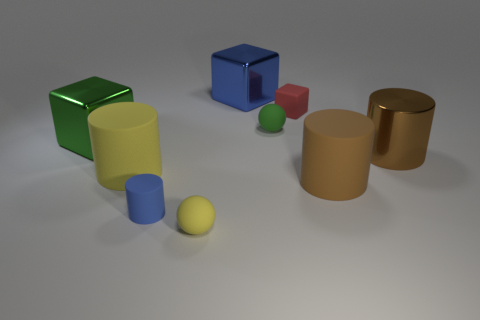Are the blue object in front of the green metal thing and the tiny green sphere made of the same material?
Your answer should be very brief. Yes. Are there the same number of small green spheres that are on the right side of the green matte object and brown things that are right of the big brown rubber cylinder?
Make the answer very short. No. What material is the other cylinder that is the same color as the shiny cylinder?
Keep it short and to the point. Rubber. What number of yellow rubber spheres are left of the large rubber thing to the right of the tiny yellow thing?
Ensure brevity in your answer.  1. There is a ball behind the metal cylinder; is it the same color as the metallic object that is on the right side of the brown matte object?
Give a very brief answer. No. What is the material of the cube that is the same size as the blue cylinder?
Keep it short and to the point. Rubber. What shape is the green thing right of the big shiny cube that is behind the tiny red rubber thing that is to the right of the big yellow object?
Make the answer very short. Sphere. What is the shape of the brown shiny object that is the same size as the yellow rubber cylinder?
Keep it short and to the point. Cylinder. There is a large metallic thing that is right of the block to the right of the big blue object; what number of yellow matte balls are behind it?
Your answer should be compact. 0. Is the number of big rubber cylinders that are in front of the big metal cylinder greater than the number of large blue blocks that are left of the tiny cylinder?
Your answer should be compact. Yes. 